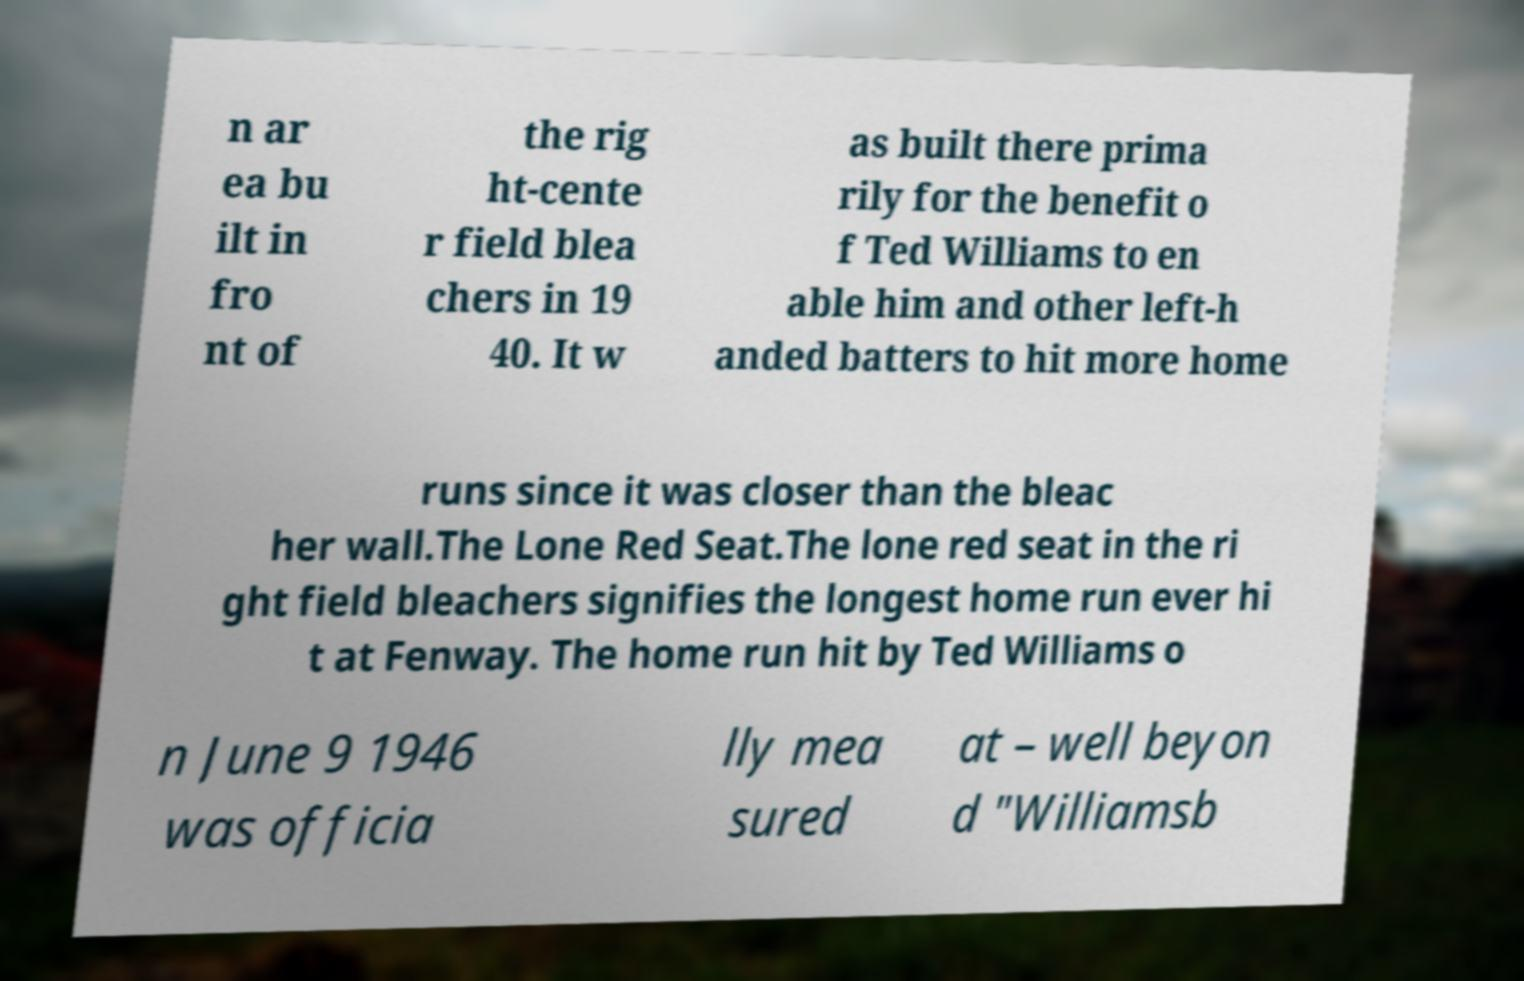Can you accurately transcribe the text from the provided image for me? n ar ea bu ilt in fro nt of the rig ht-cente r field blea chers in 19 40. It w as built there prima rily for the benefit o f Ted Williams to en able him and other left-h anded batters to hit more home runs since it was closer than the bleac her wall.The Lone Red Seat.The lone red seat in the ri ght field bleachers signifies the longest home run ever hi t at Fenway. The home run hit by Ted Williams o n June 9 1946 was officia lly mea sured at – well beyon d "Williamsb 